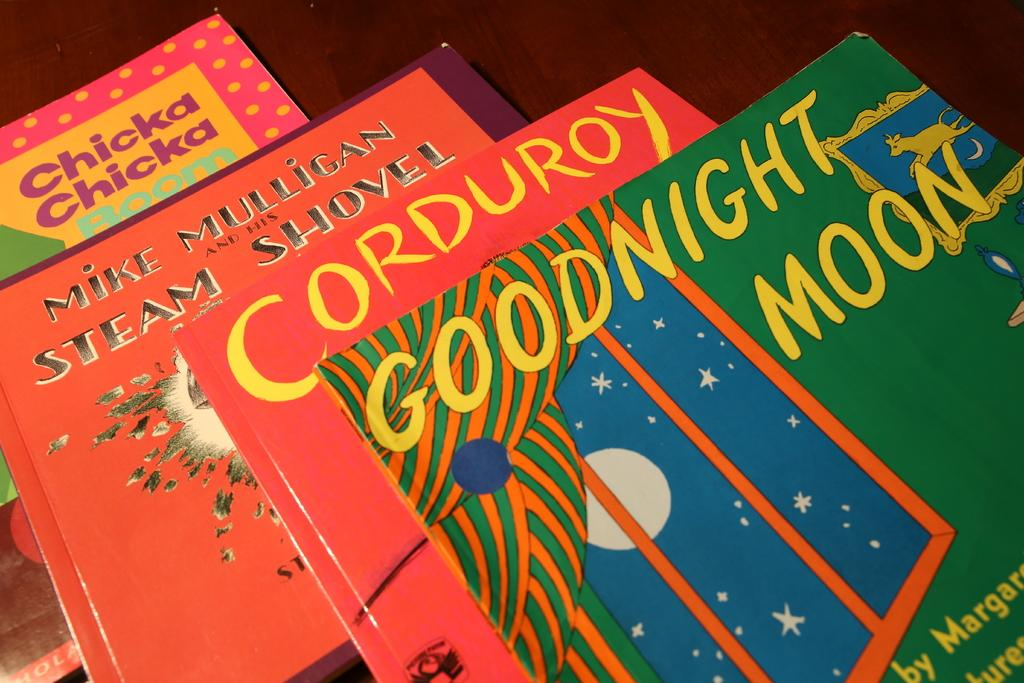<image>
Present a compact description of the photo's key features. A bunch of reddish colored books are staggered underneath a book called Goodnight Moon. 